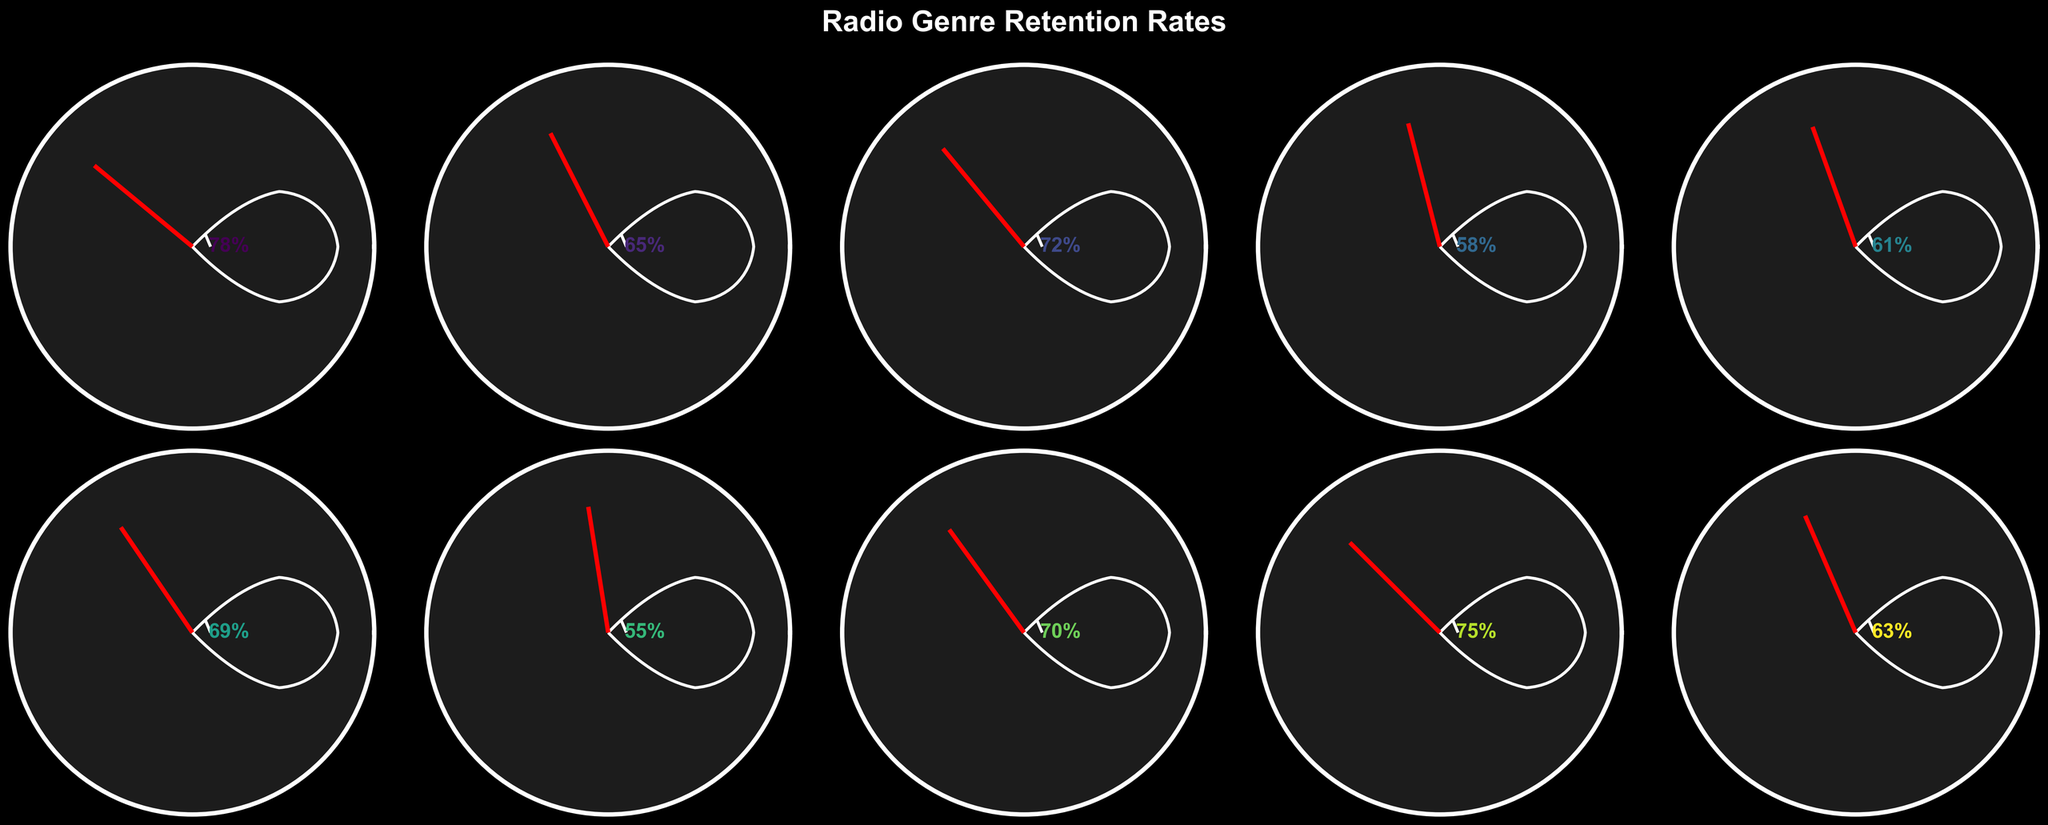which genre has the highest retention rate among local radio stations? The gauge chart indicates the retention rates for various music genres. Classic Rock has a retention rate of 78%, the highest among all listed genres.
Answer: Classic Rock what is the retention rate for jazz music? According to the gauge chart, the retention rate for Jazz is shown at 58%.
Answer: 58% how much higher is the retention rate for country music compared to hip-hop? The gauge chart shows the retention rates: Country 72% and Hip-Hop 61%. The difference is 72 - 61 = 11%.
Answer: 11% which music genre has the lowest retention rate? By examining the retention rates displayed in the gauge chart, Classical music has the lowest rate at 55%.
Answer: Classical what is the average retention rate across all genres? To find the average, sum all retention rates and divide by the number of genres: (78 + 65 + 72 + 58 + 61 + 69 + 55 + 70 + 75 + 63) / 10 = 66.6%.
Answer: 66.6% what is the retention rate difference between top 40 pop and oldies? The gauge chart shows retention rates: Top 40 Pop 65% and Oldies 75%. The difference is 75 - 65 = 10%.
Answer: 10% which genre's retention rate is closest to 70%? By inspecting the gauge chart, Country has a 72% rate and Adult Contemporary has a 70% rate. The genre closest to 70% is Adult Contemporary.
Answer: Adult Contemporary between r&b and alternative, which genre has a higher retention rate and by how much? The gauge chart shows retention rates: R&B 63% and Alternative 69%. Alternative has a higher rate by 69 - 63 = 6%.
Answer: Alternative, 6% what is the ratio of the retention rates for adult contemporary and classical? The retention rates are: Adult Contemporary 70% and Classical 55%. The ratio is 70 / 55 = 1.27.
Answer: 1.27 what percentage of the genres have a retention rate above 60%? Count the genres with retention rates above 60%: (Classic Rock, Top 40 Pop, Country, Hip-Hop, Alternative, Adult Contemporary, Oldies, R&B) = 8 out of 10. This is (8/10) × 100% = 80%.
Answer: 80% 